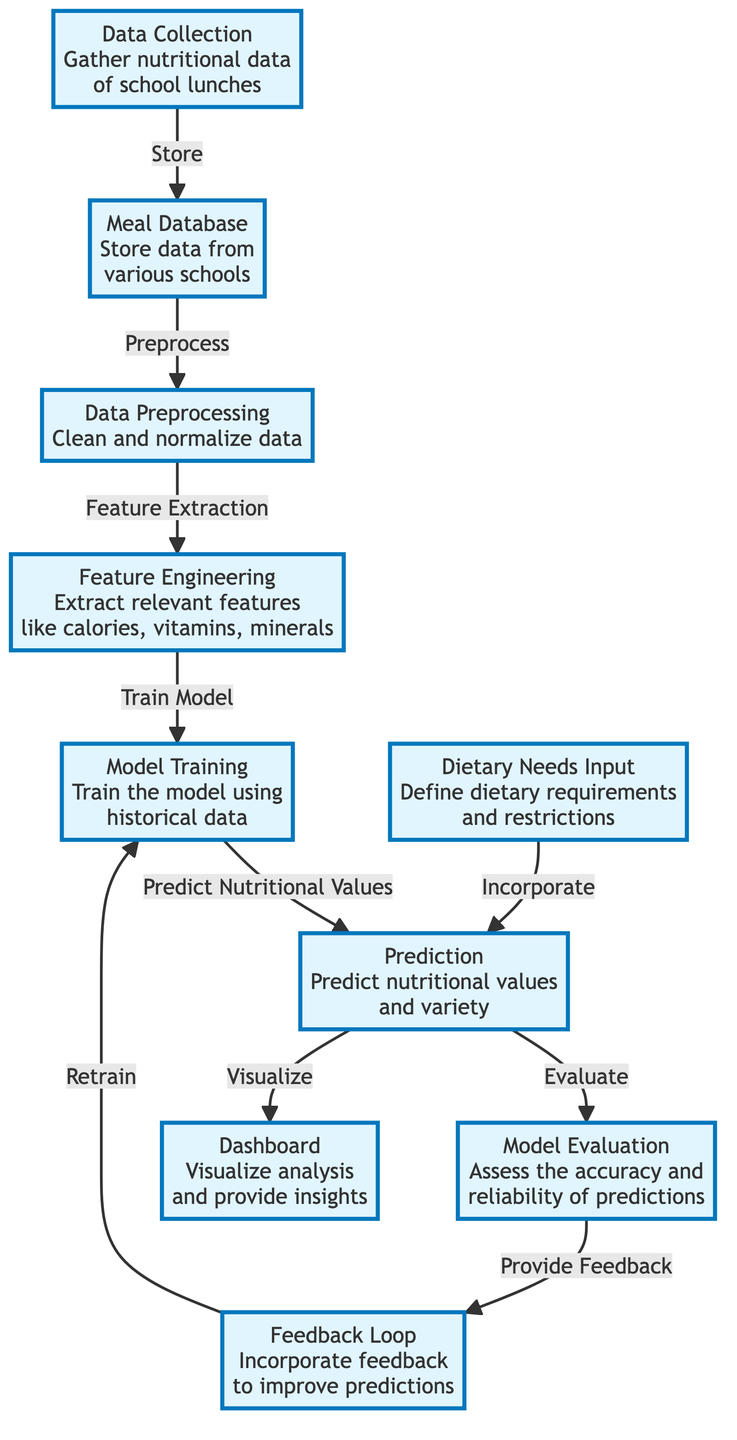What is the first step in the diagram? The first step in the diagram is "Data Collection," which gathers nutritional data of school lunches.
Answer: Data Collection How many main nodes are highlighted in the diagram? There are eight main highlighted nodes in the diagram that represent different stages of the machine learning process.
Answer: Eight Which node comes after "Data Preprocessing"? The node that comes after "Data Preprocessing" is "Feature Engineering," where relevant features are extracted.
Answer: Feature Engineering What is the purpose of the "Dietary Needs Input" node? The purpose of the "Dietary Needs Input" node is to define dietary requirements and restrictions that need to be considered in predictions.
Answer: Define dietary requirements What happens to the predictions after they are evaluated? After predictions are evaluated, they provide feedback, which is used to retrain the model.
Answer: Retrain the model What is the last node connected to "Prediction"? The last node connected to "Prediction" is "Dashboard," which visualizes the analysis and provides insights based on the predictions.
Answer: Dashboard Which two nodes directly communicate with the "Prediction" node? The two nodes that directly communicate with the "Prediction" node are "Model Training" and "Dietary Needs Input," which influence the predictions made.
Answer: Model Training and Dietary Needs Input What is the relationship between "Evaluation" and "Feedback Loop"? The relationship is that the "Evaluation" assesses the accuracy of the predictions and provides feedback that is incorporated in the "Feedback Loop" to improve predictions.
Answer: Assess accuracy and provide feedback 